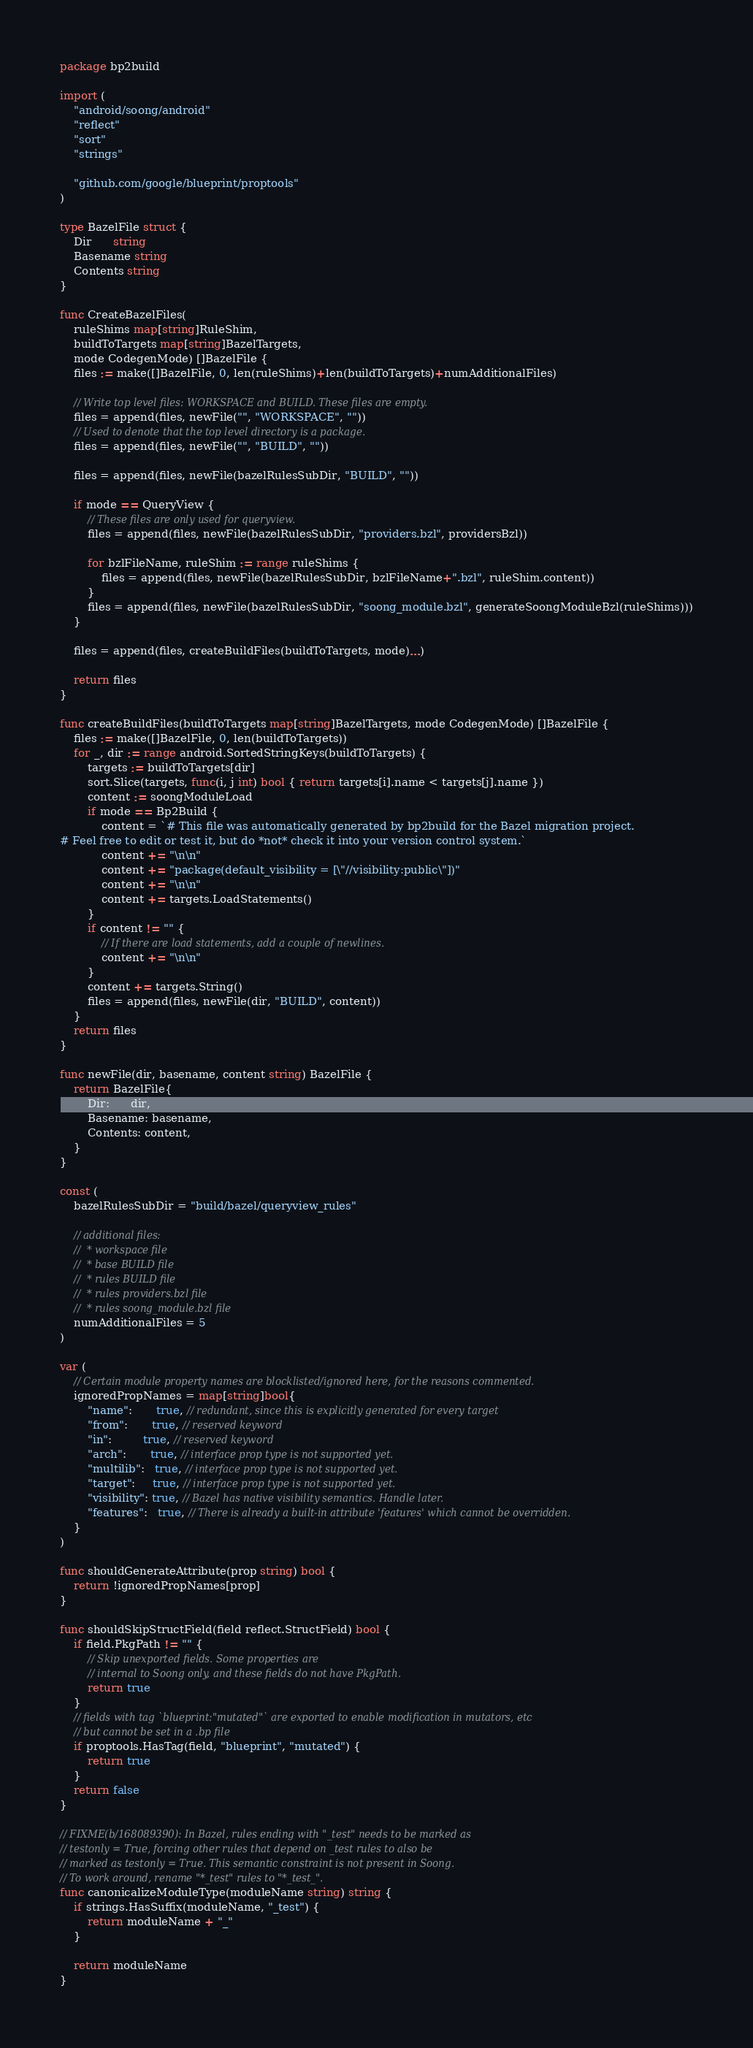Convert code to text. <code><loc_0><loc_0><loc_500><loc_500><_Go_>package bp2build

import (
	"android/soong/android"
	"reflect"
	"sort"
	"strings"

	"github.com/google/blueprint/proptools"
)

type BazelFile struct {
	Dir      string
	Basename string
	Contents string
}

func CreateBazelFiles(
	ruleShims map[string]RuleShim,
	buildToTargets map[string]BazelTargets,
	mode CodegenMode) []BazelFile {
	files := make([]BazelFile, 0, len(ruleShims)+len(buildToTargets)+numAdditionalFiles)

	// Write top level files: WORKSPACE and BUILD. These files are empty.
	files = append(files, newFile("", "WORKSPACE", ""))
	// Used to denote that the top level directory is a package.
	files = append(files, newFile("", "BUILD", ""))

	files = append(files, newFile(bazelRulesSubDir, "BUILD", ""))

	if mode == QueryView {
		// These files are only used for queryview.
		files = append(files, newFile(bazelRulesSubDir, "providers.bzl", providersBzl))

		for bzlFileName, ruleShim := range ruleShims {
			files = append(files, newFile(bazelRulesSubDir, bzlFileName+".bzl", ruleShim.content))
		}
		files = append(files, newFile(bazelRulesSubDir, "soong_module.bzl", generateSoongModuleBzl(ruleShims)))
	}

	files = append(files, createBuildFiles(buildToTargets, mode)...)

	return files
}

func createBuildFiles(buildToTargets map[string]BazelTargets, mode CodegenMode) []BazelFile {
	files := make([]BazelFile, 0, len(buildToTargets))
	for _, dir := range android.SortedStringKeys(buildToTargets) {
		targets := buildToTargets[dir]
		sort.Slice(targets, func(i, j int) bool { return targets[i].name < targets[j].name })
		content := soongModuleLoad
		if mode == Bp2Build {
			content = `# This file was automatically generated by bp2build for the Bazel migration project.
# Feel free to edit or test it, but do *not* check it into your version control system.`
			content += "\n\n"
			content += "package(default_visibility = [\"//visibility:public\"])"
			content += "\n\n"
			content += targets.LoadStatements()
		}
		if content != "" {
			// If there are load statements, add a couple of newlines.
			content += "\n\n"
		}
		content += targets.String()
		files = append(files, newFile(dir, "BUILD", content))
	}
	return files
}

func newFile(dir, basename, content string) BazelFile {
	return BazelFile{
		Dir:      dir,
		Basename: basename,
		Contents: content,
	}
}

const (
	bazelRulesSubDir = "build/bazel/queryview_rules"

	// additional files:
	//  * workspace file
	//  * base BUILD file
	//  * rules BUILD file
	//  * rules providers.bzl file
	//  * rules soong_module.bzl file
	numAdditionalFiles = 5
)

var (
	// Certain module property names are blocklisted/ignored here, for the reasons commented.
	ignoredPropNames = map[string]bool{
		"name":       true, // redundant, since this is explicitly generated for every target
		"from":       true, // reserved keyword
		"in":         true, // reserved keyword
		"arch":       true, // interface prop type is not supported yet.
		"multilib":   true, // interface prop type is not supported yet.
		"target":     true, // interface prop type is not supported yet.
		"visibility": true, // Bazel has native visibility semantics. Handle later.
		"features":   true, // There is already a built-in attribute 'features' which cannot be overridden.
	}
)

func shouldGenerateAttribute(prop string) bool {
	return !ignoredPropNames[prop]
}

func shouldSkipStructField(field reflect.StructField) bool {
	if field.PkgPath != "" {
		// Skip unexported fields. Some properties are
		// internal to Soong only, and these fields do not have PkgPath.
		return true
	}
	// fields with tag `blueprint:"mutated"` are exported to enable modification in mutators, etc
	// but cannot be set in a .bp file
	if proptools.HasTag(field, "blueprint", "mutated") {
		return true
	}
	return false
}

// FIXME(b/168089390): In Bazel, rules ending with "_test" needs to be marked as
// testonly = True, forcing other rules that depend on _test rules to also be
// marked as testonly = True. This semantic constraint is not present in Soong.
// To work around, rename "*_test" rules to "*_test_".
func canonicalizeModuleType(moduleName string) string {
	if strings.HasSuffix(moduleName, "_test") {
		return moduleName + "_"
	}

	return moduleName
}
</code> 